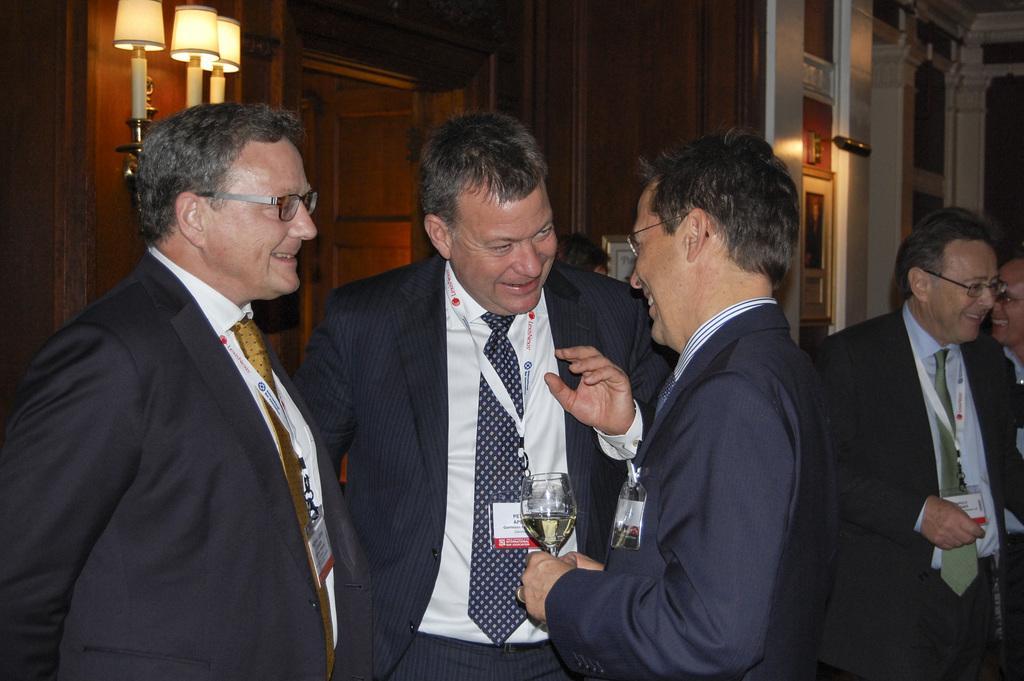Could you give a brief overview of what you see in this image? In this image we can see four persons are standing. They are wearing suits and ID cards in their neck. One person is holding glass. Background of the image wall, door and lights are present. 